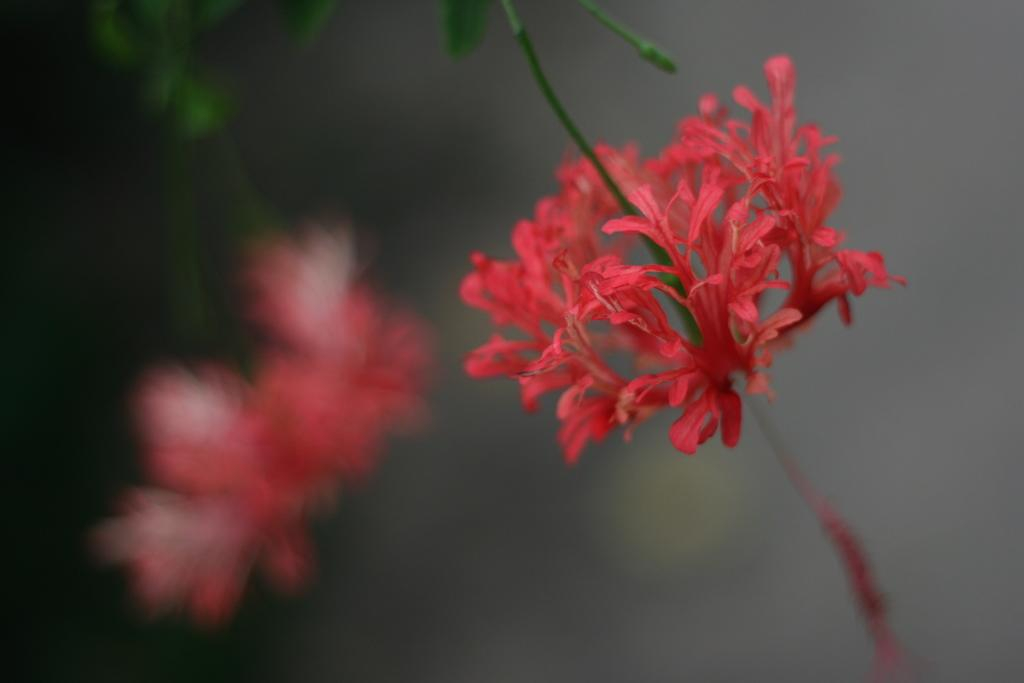What type of flower is in the image? There is a red color flower in the image. What is the flower attached to? The flower is part of a plant. What stage of growth is the plant in? The plant has a bud. What else can be seen on the plant besides the flower? The plant has leaves. How many flowers are visible in the image? There are two flowers visible in the image, one on the main plant and another on a separate plant on the left side. How many children are playing on the top of the flower in the image? There are no children present in the image, and the flower is not large enough to accommodate any play. 